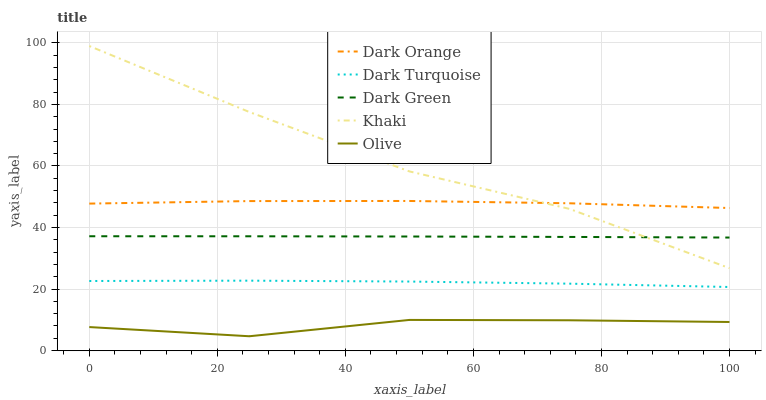Does Olive have the minimum area under the curve?
Answer yes or no. Yes. Does Khaki have the maximum area under the curve?
Answer yes or no. Yes. Does Dark Orange have the minimum area under the curve?
Answer yes or no. No. Does Dark Orange have the maximum area under the curve?
Answer yes or no. No. Is Dark Green the smoothest?
Answer yes or no. Yes. Is Khaki the roughest?
Answer yes or no. Yes. Is Dark Orange the smoothest?
Answer yes or no. No. Is Dark Orange the roughest?
Answer yes or no. No. Does Olive have the lowest value?
Answer yes or no. Yes. Does Dark Green have the lowest value?
Answer yes or no. No. Does Khaki have the highest value?
Answer yes or no. Yes. Does Dark Orange have the highest value?
Answer yes or no. No. Is Dark Green less than Dark Orange?
Answer yes or no. Yes. Is Dark Orange greater than Dark Turquoise?
Answer yes or no. Yes. Does Dark Orange intersect Khaki?
Answer yes or no. Yes. Is Dark Orange less than Khaki?
Answer yes or no. No. Is Dark Orange greater than Khaki?
Answer yes or no. No. Does Dark Green intersect Dark Orange?
Answer yes or no. No. 